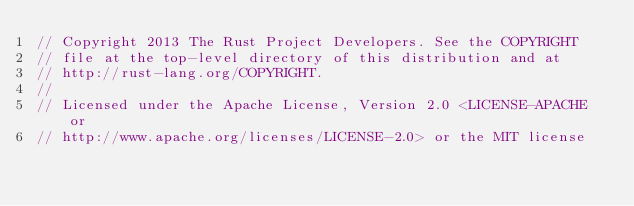Convert code to text. <code><loc_0><loc_0><loc_500><loc_500><_Rust_>// Copyright 2013 The Rust Project Developers. See the COPYRIGHT
// file at the top-level directory of this distribution and at
// http://rust-lang.org/COPYRIGHT.
//
// Licensed under the Apache License, Version 2.0 <LICENSE-APACHE or
// http://www.apache.org/licenses/LICENSE-2.0> or the MIT license</code> 